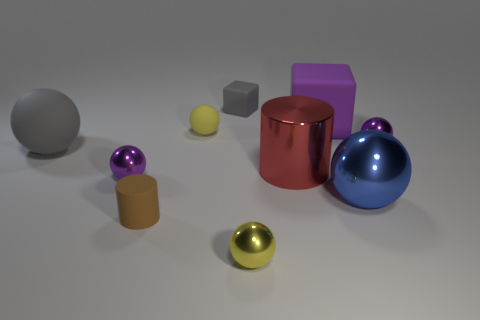How many things are either rubber objects that are right of the gray matte block or metal things that are on the right side of the big purple matte block? Observing the image carefully, there appears to be one rubber object to the right of the gray matte block and two metal objects on the right side of the large purple matte block, making a total of three such items as per the criteria specified in your question. 